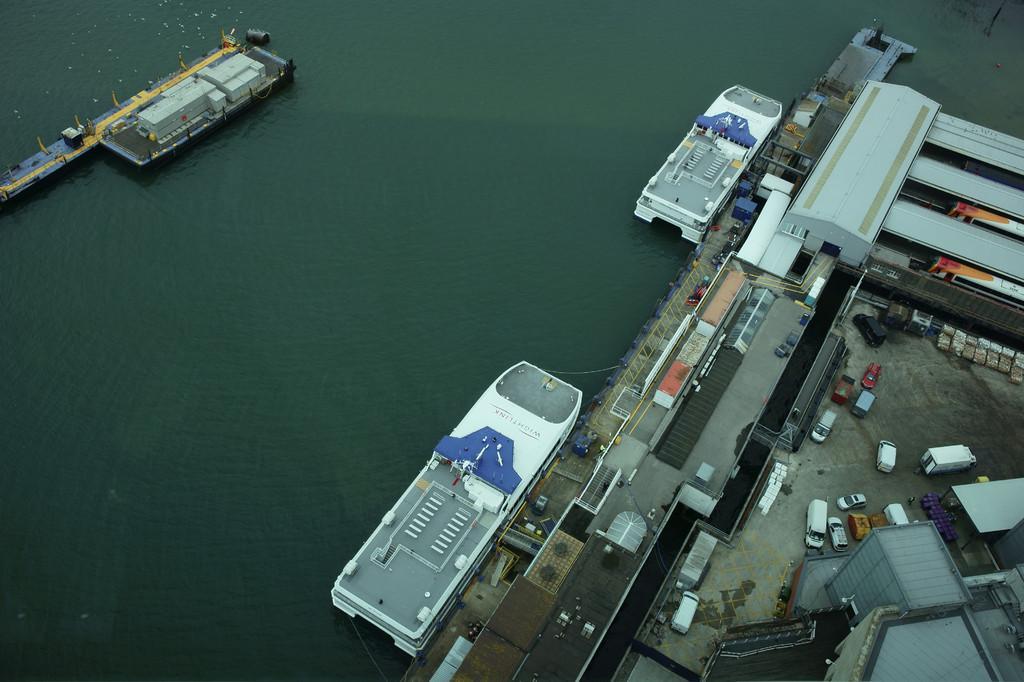In one or two sentences, can you explain what this image depicts? In this image, I can see ships on the water and there are sheds, a building, vehicles and some objects. On the left side of the image, I can see sheds on a platform. 